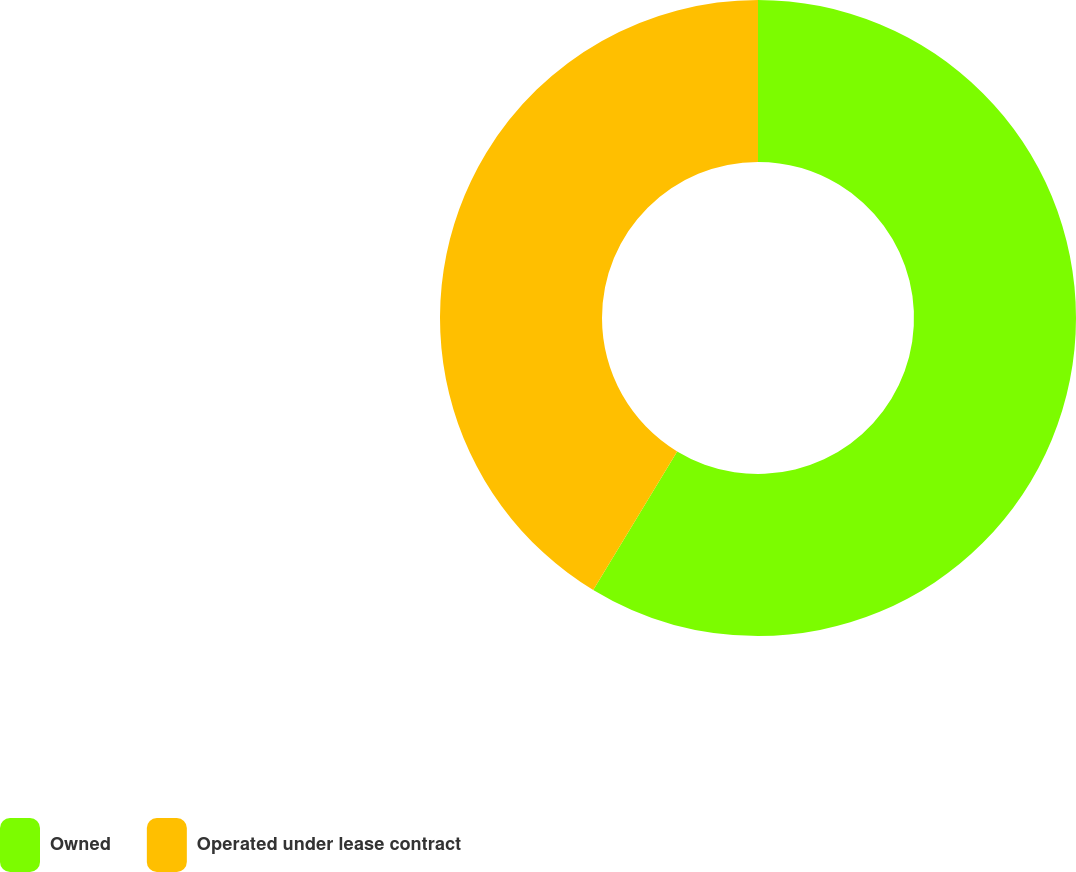<chart> <loc_0><loc_0><loc_500><loc_500><pie_chart><fcel>Owned<fcel>Operated under lease contract<nl><fcel>58.67%<fcel>41.33%<nl></chart> 